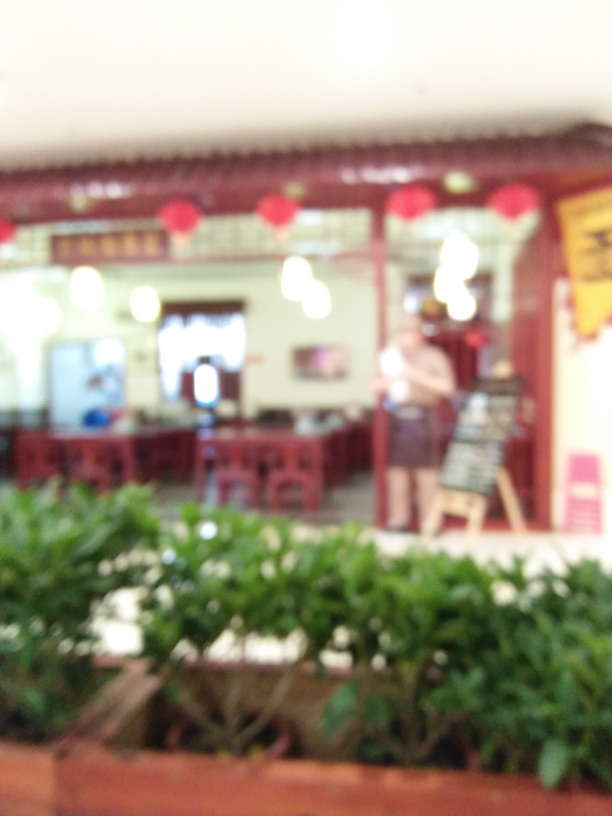Is there any cultural significance to the decor seen in the image? From what we can tell, there are red lanterns which are often associated with East Asian cultures and are commonly used in celebrations. They can represent joy, fortune, and prosperity, especially if this setting is a place where people gather, such as a restaurant. Could this image be from a special event? It's possible. Red lanterns are often hung during festivals or special occasions. The fact that they are present might indicate a celebratory event or that the place is decorated for a festive season. 